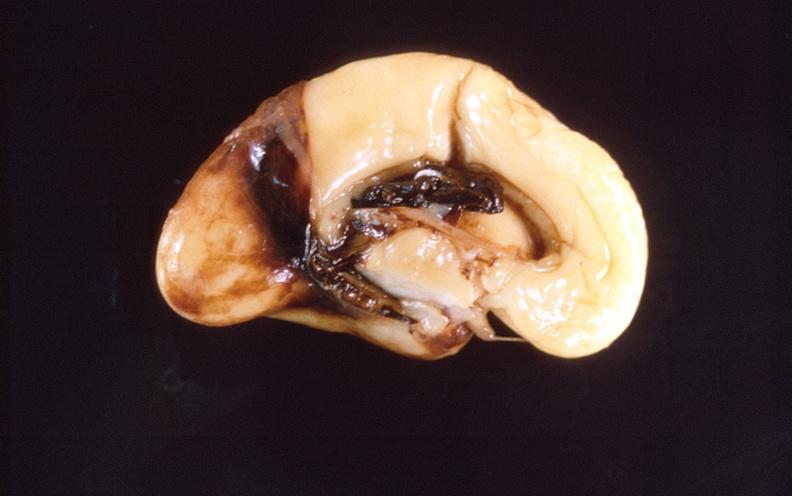does nodular tumor show intraventricular hemorrhage, neonate brain?
Answer the question using a single word or phrase. No 